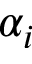Convert formula to latex. <formula><loc_0><loc_0><loc_500><loc_500>\alpha _ { i }</formula> 